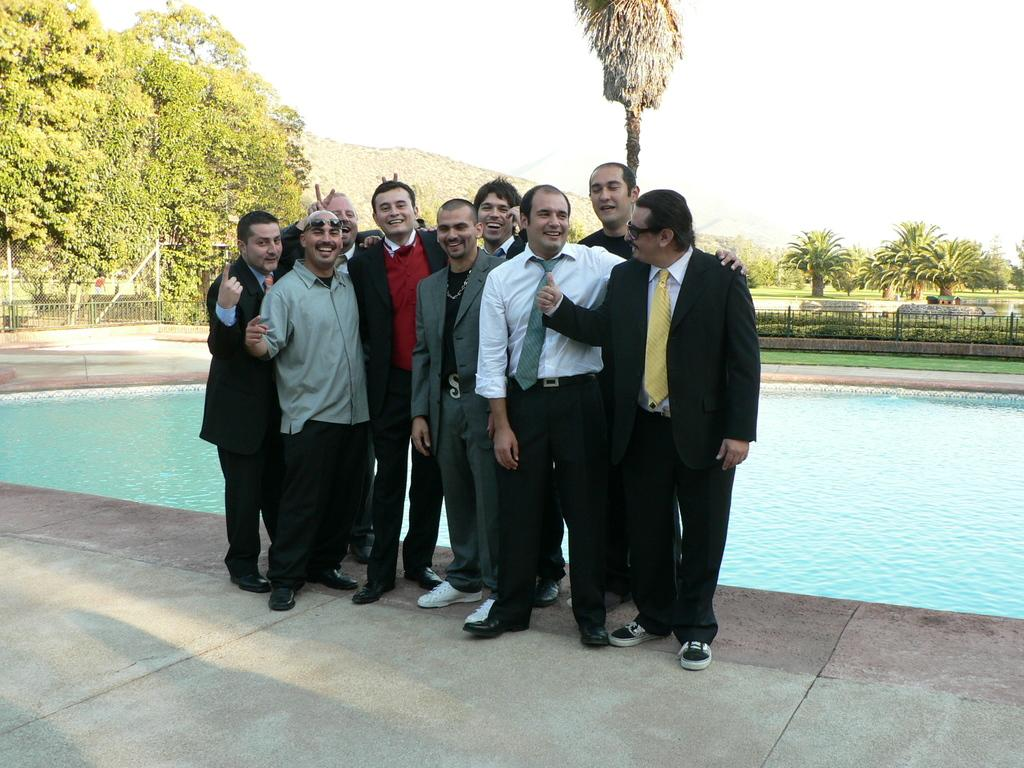What are the men in the image wearing? The men in the image are wearing suits. Where are the men standing in the image? The men are standing in front of a pool. What expression do the men have in the image? The men are smiling in the image. What can be seen in the background of the image? There are trees in the background of the image. What type of landscape is visible behind the trees? The trees are on a grassland. What is visible at the top of the image? The sky is visible in the image. What type of badge is the mom wearing in the image? There is no mom or badge present in the image. What value does the image represent? The image does not represent a specific value; it is a scene of men standing in front of a pool. 